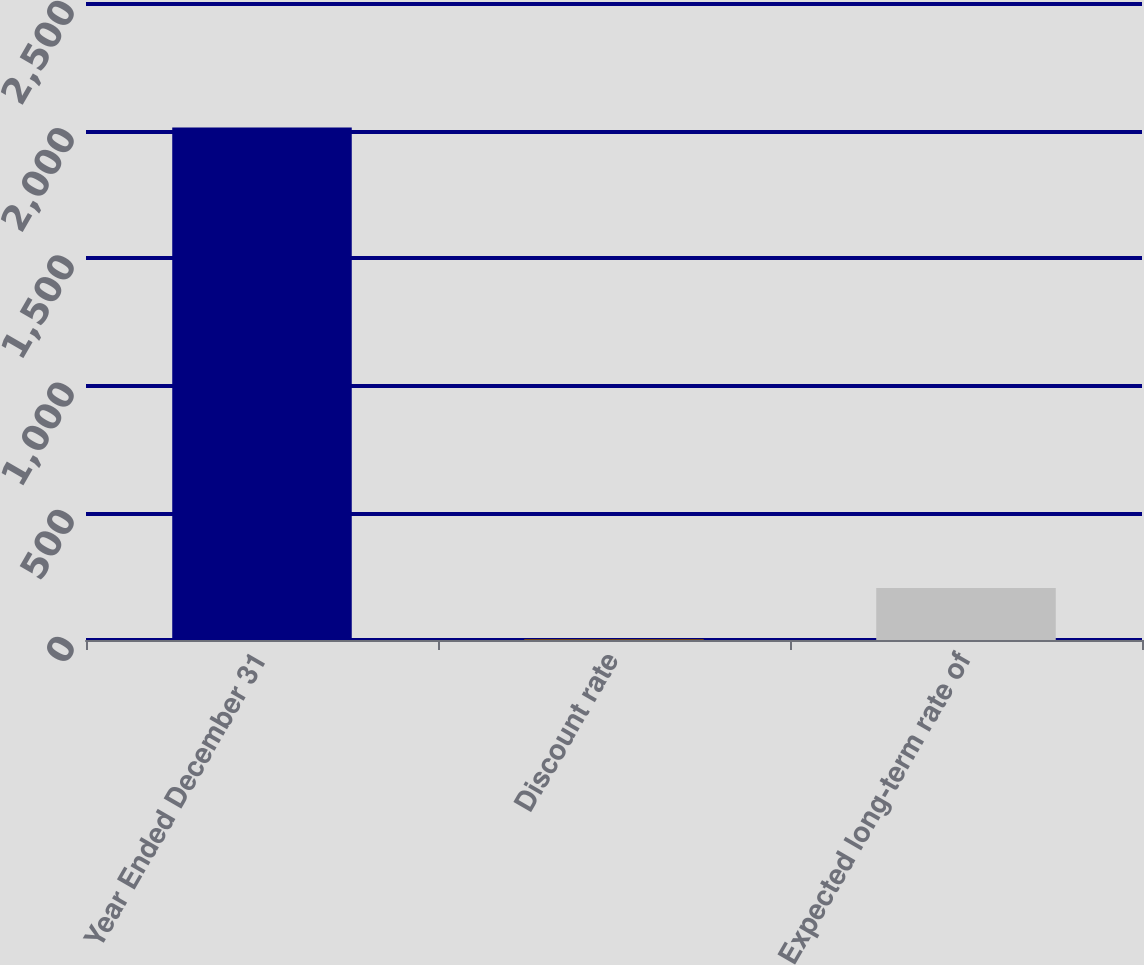Convert chart. <chart><loc_0><loc_0><loc_500><loc_500><bar_chart><fcel>Year Ended December 31<fcel>Discount rate<fcel>Expected long-term rate of<nl><fcel>2015<fcel>3.75<fcel>204.88<nl></chart> 